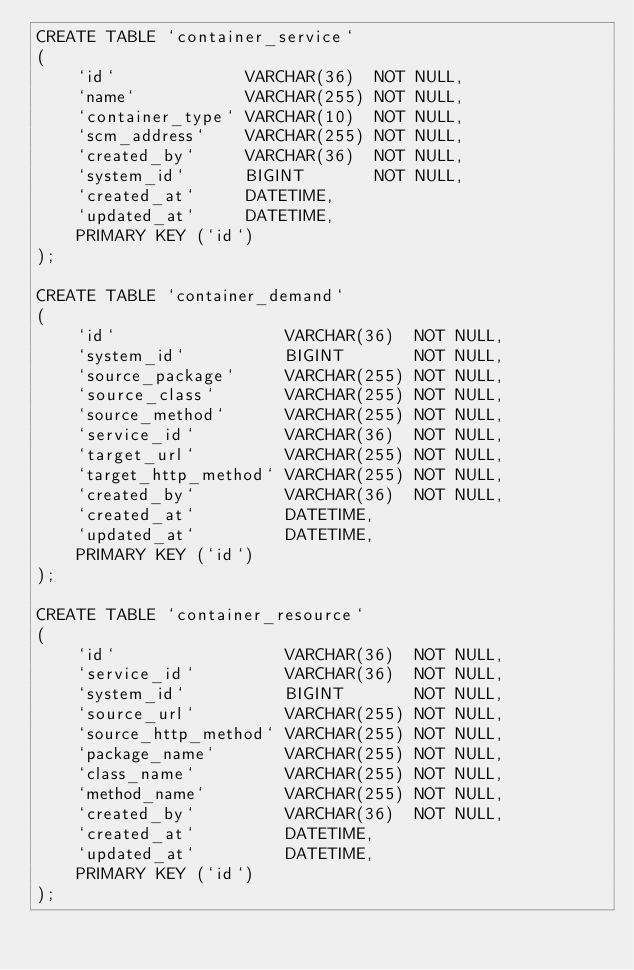Convert code to text. <code><loc_0><loc_0><loc_500><loc_500><_SQL_>CREATE TABLE `container_service`
(
    `id`             VARCHAR(36)  NOT NULL,
    `name`           VARCHAR(255) NOT NULL,
    `container_type` VARCHAR(10)  NOT NULL,
    `scm_address`    VARCHAR(255) NOT NULL,
    `created_by`     VARCHAR(36)  NOT NULL,
    `system_id`      BIGINT       NOT NULL,
    `created_at`     DATETIME,
    `updated_at`     DATETIME,
    PRIMARY KEY (`id`)
);

CREATE TABLE `container_demand`
(
    `id`                 VARCHAR(36)  NOT NULL,
    `system_id`          BIGINT       NOT NULL,
    `source_package`     VARCHAR(255) NOT NULL,
    `source_class`       VARCHAR(255) NOT NULL,
    `source_method`      VARCHAR(255) NOT NULL,
    `service_id`         VARCHAR(36)  NOT NULL,
    `target_url`         VARCHAR(255) NOT NULL,
    `target_http_method` VARCHAR(255) NOT NULL,
    `created_by`         VARCHAR(36)  NOT NULL,
    `created_at`         DATETIME,
    `updated_at`         DATETIME,
    PRIMARY KEY (`id`)
);

CREATE TABLE `container_resource`
(
    `id`                 VARCHAR(36)  NOT NULL,
    `service_id`         VARCHAR(36)  NOT NULL,
    `system_id`          BIGINT       NOT NULL,
    `source_url`         VARCHAR(255) NOT NULL,
    `source_http_method` VARCHAR(255) NOT NULL,
    `package_name`       VARCHAR(255) NOT NULL,
    `class_name`         VARCHAR(255) NOT NULL,
    `method_name`        VARCHAR(255) NOT NULL,
    `created_by`         VARCHAR(36)  NOT NULL,
    `created_at`         DATETIME,
    `updated_at`         DATETIME,
    PRIMARY KEY (`id`)
);
</code> 